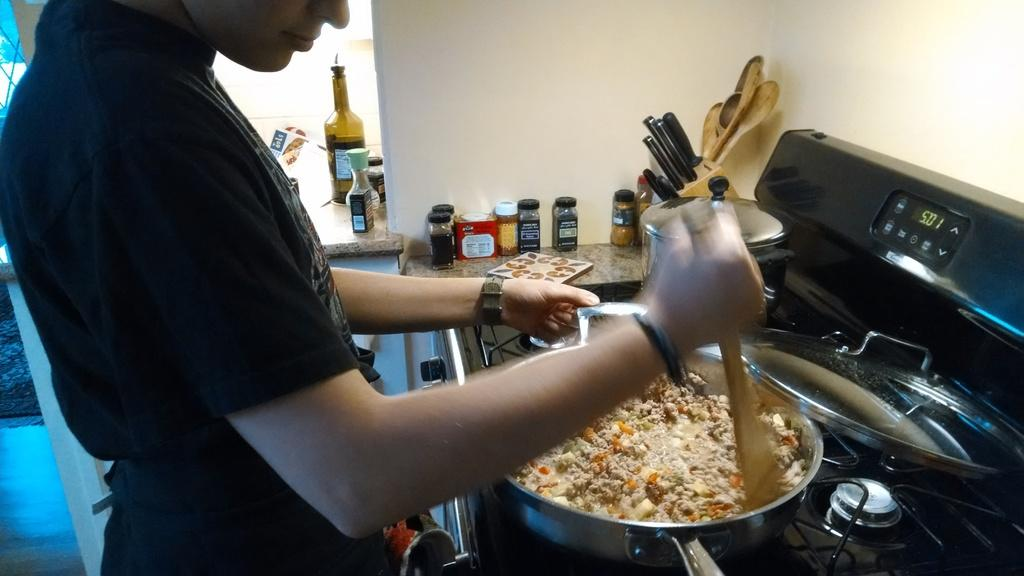What is the person in the image doing? The person is cooking food in a pan. What is the person using to cook the food? The person is using a gas stove to cook the food. What other items can be seen in the image related to cooking? There are utensils and jars visible in the image. What type of birds can be seen flying around the person in the image? There are no birds visible in the image. How does the person show respect to the cooking process in the image? The image does not provide information about the person's attitude or respect towards the cooking process. 